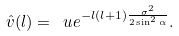Convert formula to latex. <formula><loc_0><loc_0><loc_500><loc_500>\hat { v } ( l ) = \ u e ^ { - l ( l + 1 ) \frac { \sigma ^ { 2 } } { 2 \sin ^ { 2 } \alpha } } .</formula> 